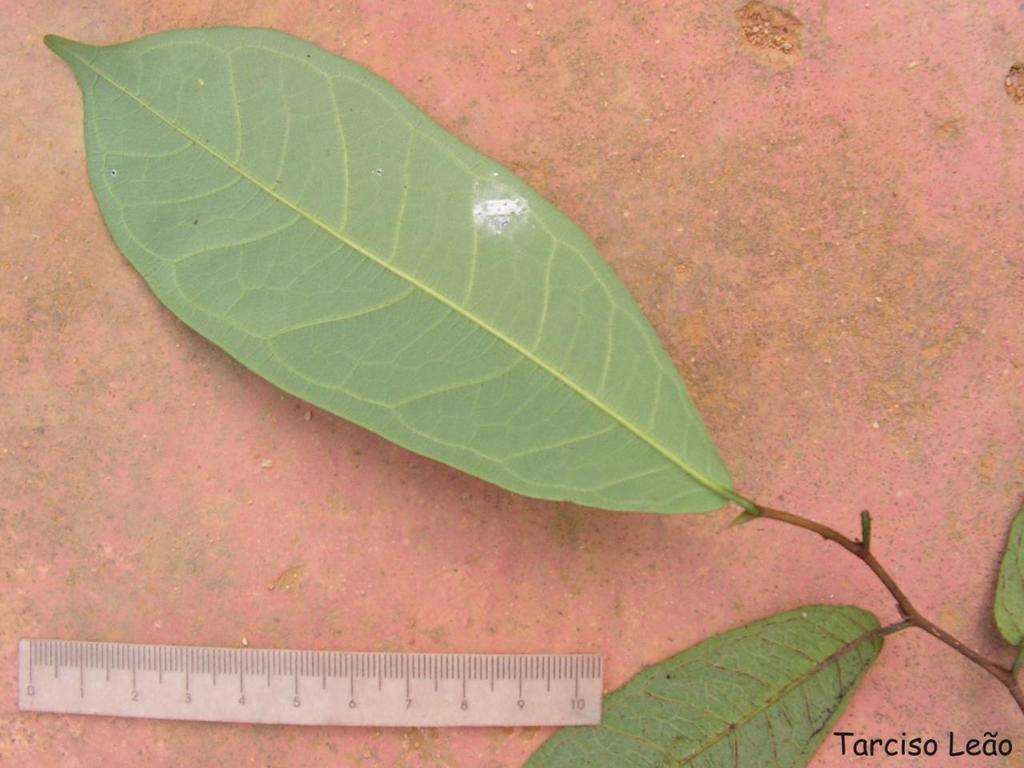Who took this photo?
Make the answer very short. Tarciso leao. How big is the ruler?
Your response must be concise. 10. 